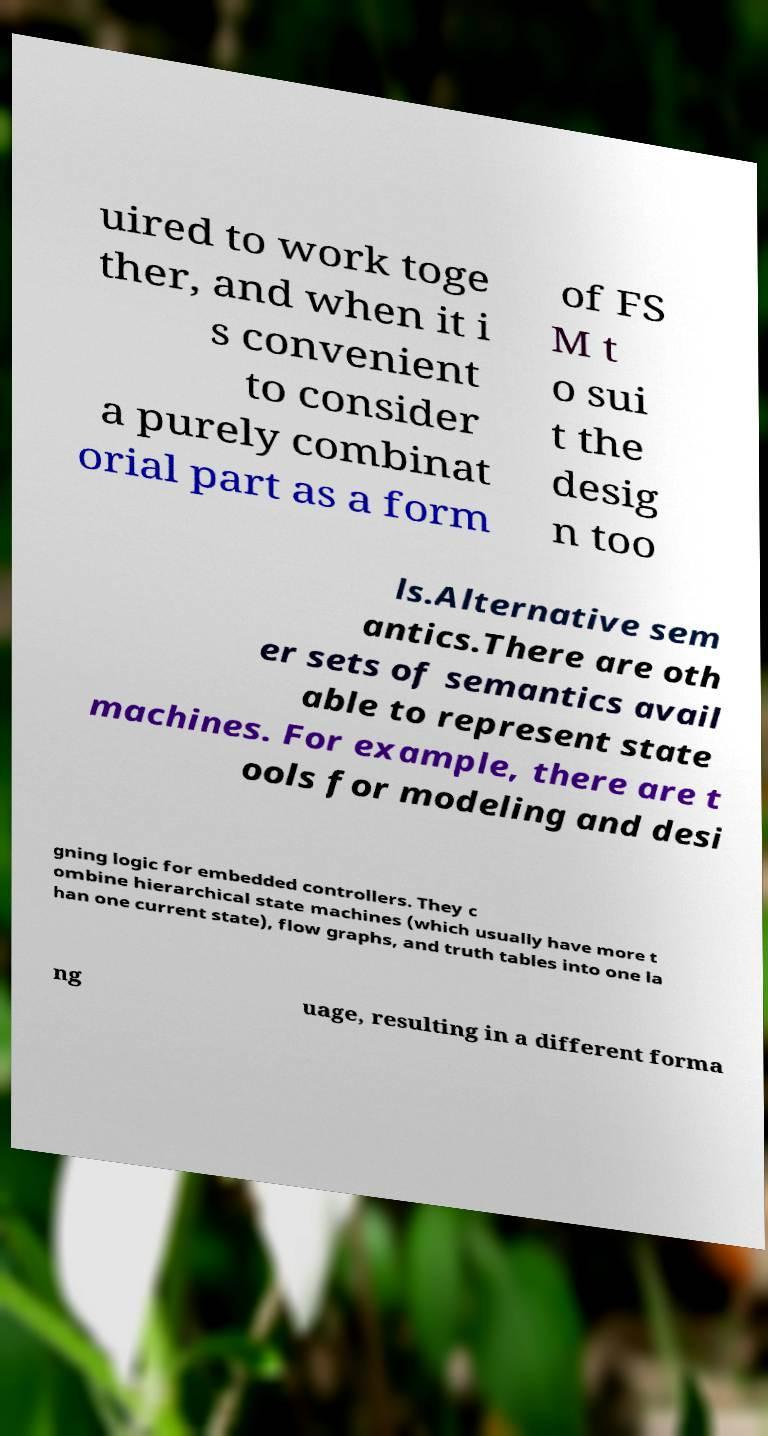Could you extract and type out the text from this image? uired to work toge ther, and when it i s convenient to consider a purely combinat orial part as a form of FS M t o sui t the desig n too ls.Alternative sem antics.There are oth er sets of semantics avail able to represent state machines. For example, there are t ools for modeling and desi gning logic for embedded controllers. They c ombine hierarchical state machines (which usually have more t han one current state), flow graphs, and truth tables into one la ng uage, resulting in a different forma 